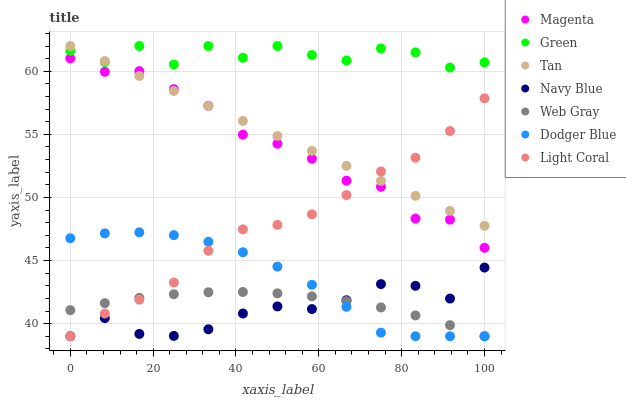Does Navy Blue have the minimum area under the curve?
Answer yes or no. Yes. Does Green have the maximum area under the curve?
Answer yes or no. Yes. Does Light Coral have the minimum area under the curve?
Answer yes or no. No. Does Light Coral have the maximum area under the curve?
Answer yes or no. No. Is Tan the smoothest?
Answer yes or no. Yes. Is Green the roughest?
Answer yes or no. Yes. Is Navy Blue the smoothest?
Answer yes or no. No. Is Navy Blue the roughest?
Answer yes or no. No. Does Web Gray have the lowest value?
Answer yes or no. Yes. Does Light Coral have the lowest value?
Answer yes or no. No. Does Tan have the highest value?
Answer yes or no. Yes. Does Navy Blue have the highest value?
Answer yes or no. No. Is Web Gray less than Tan?
Answer yes or no. Yes. Is Magenta greater than Dodger Blue?
Answer yes or no. Yes. Does Tan intersect Magenta?
Answer yes or no. Yes. Is Tan less than Magenta?
Answer yes or no. No. Is Tan greater than Magenta?
Answer yes or no. No. Does Web Gray intersect Tan?
Answer yes or no. No. 